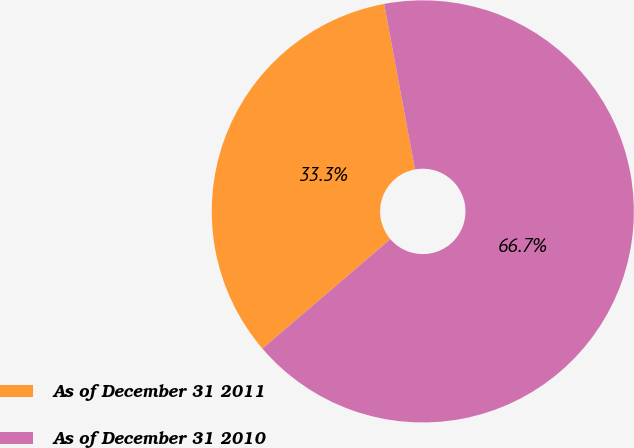Convert chart. <chart><loc_0><loc_0><loc_500><loc_500><pie_chart><fcel>As of December 31 2011<fcel>As of December 31 2010<nl><fcel>33.33%<fcel>66.67%<nl></chart> 